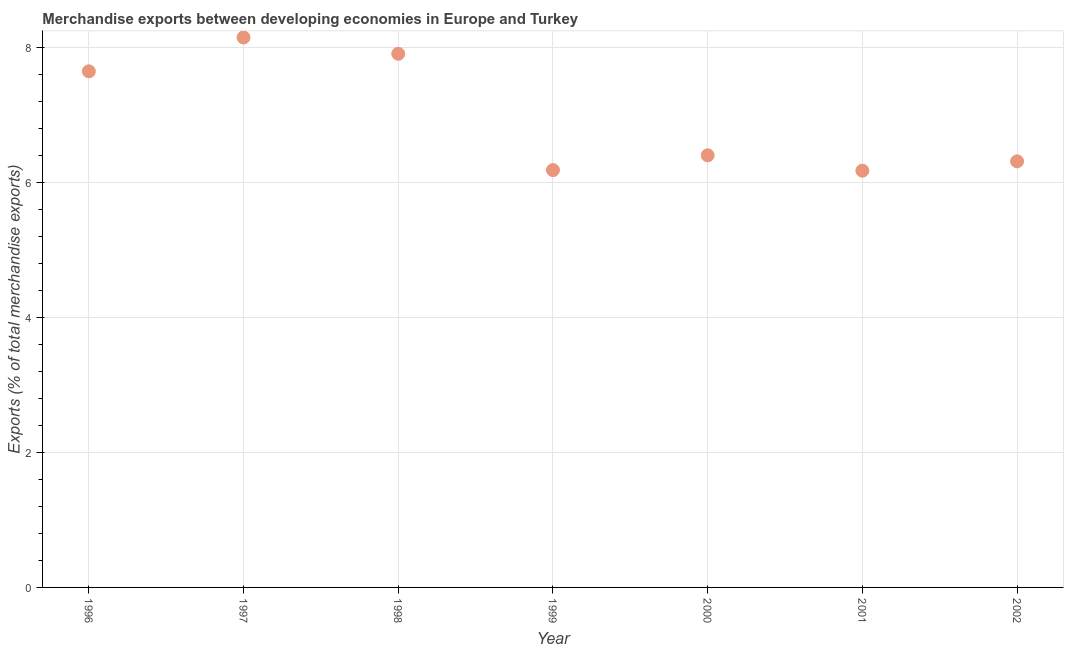What is the merchandise exports in 2000?
Your answer should be compact. 6.41. Across all years, what is the maximum merchandise exports?
Offer a very short reply. 8.15. Across all years, what is the minimum merchandise exports?
Give a very brief answer. 6.18. What is the sum of the merchandise exports?
Your answer should be compact. 48.81. What is the difference between the merchandise exports in 1997 and 2001?
Your response must be concise. 1.98. What is the average merchandise exports per year?
Your answer should be very brief. 6.97. What is the median merchandise exports?
Provide a short and direct response. 6.41. What is the ratio of the merchandise exports in 1997 to that in 1998?
Keep it short and to the point. 1.03. Is the merchandise exports in 2000 less than that in 2002?
Give a very brief answer. No. What is the difference between the highest and the second highest merchandise exports?
Offer a terse response. 0.24. What is the difference between the highest and the lowest merchandise exports?
Offer a terse response. 1.98. In how many years, is the merchandise exports greater than the average merchandise exports taken over all years?
Offer a very short reply. 3. Does the merchandise exports monotonically increase over the years?
Make the answer very short. No. What is the difference between two consecutive major ticks on the Y-axis?
Make the answer very short. 2. Does the graph contain any zero values?
Provide a short and direct response. No. What is the title of the graph?
Provide a short and direct response. Merchandise exports between developing economies in Europe and Turkey. What is the label or title of the Y-axis?
Your answer should be very brief. Exports (% of total merchandise exports). What is the Exports (% of total merchandise exports) in 1996?
Offer a terse response. 7.65. What is the Exports (% of total merchandise exports) in 1997?
Ensure brevity in your answer.  8.15. What is the Exports (% of total merchandise exports) in 1998?
Your response must be concise. 7.91. What is the Exports (% of total merchandise exports) in 1999?
Your answer should be compact. 6.19. What is the Exports (% of total merchandise exports) in 2000?
Keep it short and to the point. 6.41. What is the Exports (% of total merchandise exports) in 2001?
Your answer should be compact. 6.18. What is the Exports (% of total merchandise exports) in 2002?
Keep it short and to the point. 6.32. What is the difference between the Exports (% of total merchandise exports) in 1996 and 1997?
Your response must be concise. -0.5. What is the difference between the Exports (% of total merchandise exports) in 1996 and 1998?
Your response must be concise. -0.26. What is the difference between the Exports (% of total merchandise exports) in 1996 and 1999?
Your answer should be very brief. 1.46. What is the difference between the Exports (% of total merchandise exports) in 1996 and 2000?
Make the answer very short. 1.24. What is the difference between the Exports (% of total merchandise exports) in 1996 and 2001?
Keep it short and to the point. 1.47. What is the difference between the Exports (% of total merchandise exports) in 1996 and 2002?
Your answer should be very brief. 1.33. What is the difference between the Exports (% of total merchandise exports) in 1997 and 1998?
Ensure brevity in your answer.  0.24. What is the difference between the Exports (% of total merchandise exports) in 1997 and 1999?
Give a very brief answer. 1.97. What is the difference between the Exports (% of total merchandise exports) in 1997 and 2000?
Your response must be concise. 1.75. What is the difference between the Exports (% of total merchandise exports) in 1997 and 2001?
Provide a short and direct response. 1.98. What is the difference between the Exports (% of total merchandise exports) in 1997 and 2002?
Provide a succinct answer. 1.84. What is the difference between the Exports (% of total merchandise exports) in 1998 and 1999?
Provide a short and direct response. 1.72. What is the difference between the Exports (% of total merchandise exports) in 1998 and 2000?
Keep it short and to the point. 1.51. What is the difference between the Exports (% of total merchandise exports) in 1998 and 2001?
Keep it short and to the point. 1.73. What is the difference between the Exports (% of total merchandise exports) in 1998 and 2002?
Provide a short and direct response. 1.59. What is the difference between the Exports (% of total merchandise exports) in 1999 and 2000?
Your response must be concise. -0.22. What is the difference between the Exports (% of total merchandise exports) in 1999 and 2001?
Ensure brevity in your answer.  0.01. What is the difference between the Exports (% of total merchandise exports) in 1999 and 2002?
Make the answer very short. -0.13. What is the difference between the Exports (% of total merchandise exports) in 2000 and 2001?
Keep it short and to the point. 0.23. What is the difference between the Exports (% of total merchandise exports) in 2000 and 2002?
Give a very brief answer. 0.09. What is the difference between the Exports (% of total merchandise exports) in 2001 and 2002?
Your answer should be very brief. -0.14. What is the ratio of the Exports (% of total merchandise exports) in 1996 to that in 1997?
Your answer should be compact. 0.94. What is the ratio of the Exports (% of total merchandise exports) in 1996 to that in 1998?
Ensure brevity in your answer.  0.97. What is the ratio of the Exports (% of total merchandise exports) in 1996 to that in 1999?
Offer a terse response. 1.24. What is the ratio of the Exports (% of total merchandise exports) in 1996 to that in 2000?
Offer a very short reply. 1.19. What is the ratio of the Exports (% of total merchandise exports) in 1996 to that in 2001?
Give a very brief answer. 1.24. What is the ratio of the Exports (% of total merchandise exports) in 1996 to that in 2002?
Provide a succinct answer. 1.21. What is the ratio of the Exports (% of total merchandise exports) in 1997 to that in 1998?
Offer a terse response. 1.03. What is the ratio of the Exports (% of total merchandise exports) in 1997 to that in 1999?
Your answer should be compact. 1.32. What is the ratio of the Exports (% of total merchandise exports) in 1997 to that in 2000?
Offer a terse response. 1.27. What is the ratio of the Exports (% of total merchandise exports) in 1997 to that in 2001?
Make the answer very short. 1.32. What is the ratio of the Exports (% of total merchandise exports) in 1997 to that in 2002?
Keep it short and to the point. 1.29. What is the ratio of the Exports (% of total merchandise exports) in 1998 to that in 1999?
Make the answer very short. 1.28. What is the ratio of the Exports (% of total merchandise exports) in 1998 to that in 2000?
Offer a terse response. 1.24. What is the ratio of the Exports (% of total merchandise exports) in 1998 to that in 2001?
Provide a succinct answer. 1.28. What is the ratio of the Exports (% of total merchandise exports) in 1998 to that in 2002?
Give a very brief answer. 1.25. What is the ratio of the Exports (% of total merchandise exports) in 1999 to that in 2000?
Keep it short and to the point. 0.97. What is the ratio of the Exports (% of total merchandise exports) in 1999 to that in 2002?
Your response must be concise. 0.98. What is the ratio of the Exports (% of total merchandise exports) in 2001 to that in 2002?
Keep it short and to the point. 0.98. 